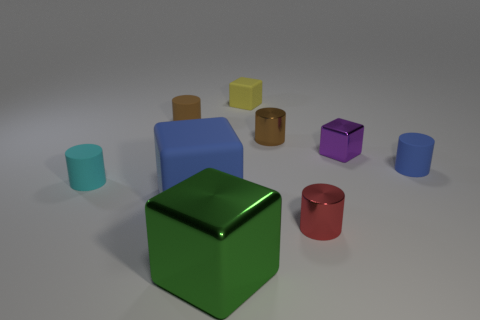Subtract 2 cylinders. How many cylinders are left? 3 Add 1 tiny brown rubber cylinders. How many objects exist? 10 Subtract all purple metal blocks. How many blocks are left? 3 Subtract all cyan cylinders. How many cylinders are left? 4 Subtract all cyan cylinders. Subtract all gray cubes. How many cylinders are left? 4 Subtract all blocks. How many objects are left? 5 Subtract all brown matte cylinders. Subtract all green shiny cubes. How many objects are left? 7 Add 7 large blue things. How many large blue things are left? 8 Add 3 tiny purple cylinders. How many tiny purple cylinders exist? 3 Subtract 0 green balls. How many objects are left? 9 